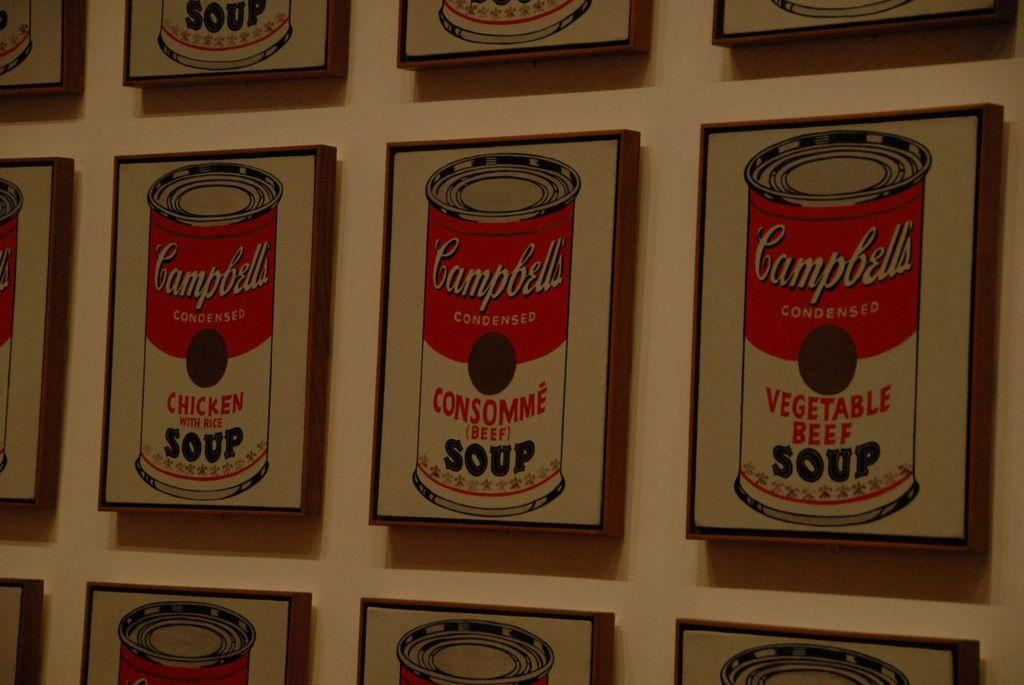<image>
Summarize the visual content of the image. Several paintings of Campbells' condensed soup are on the wall, with different flavors like chicken and vegetable beef. 